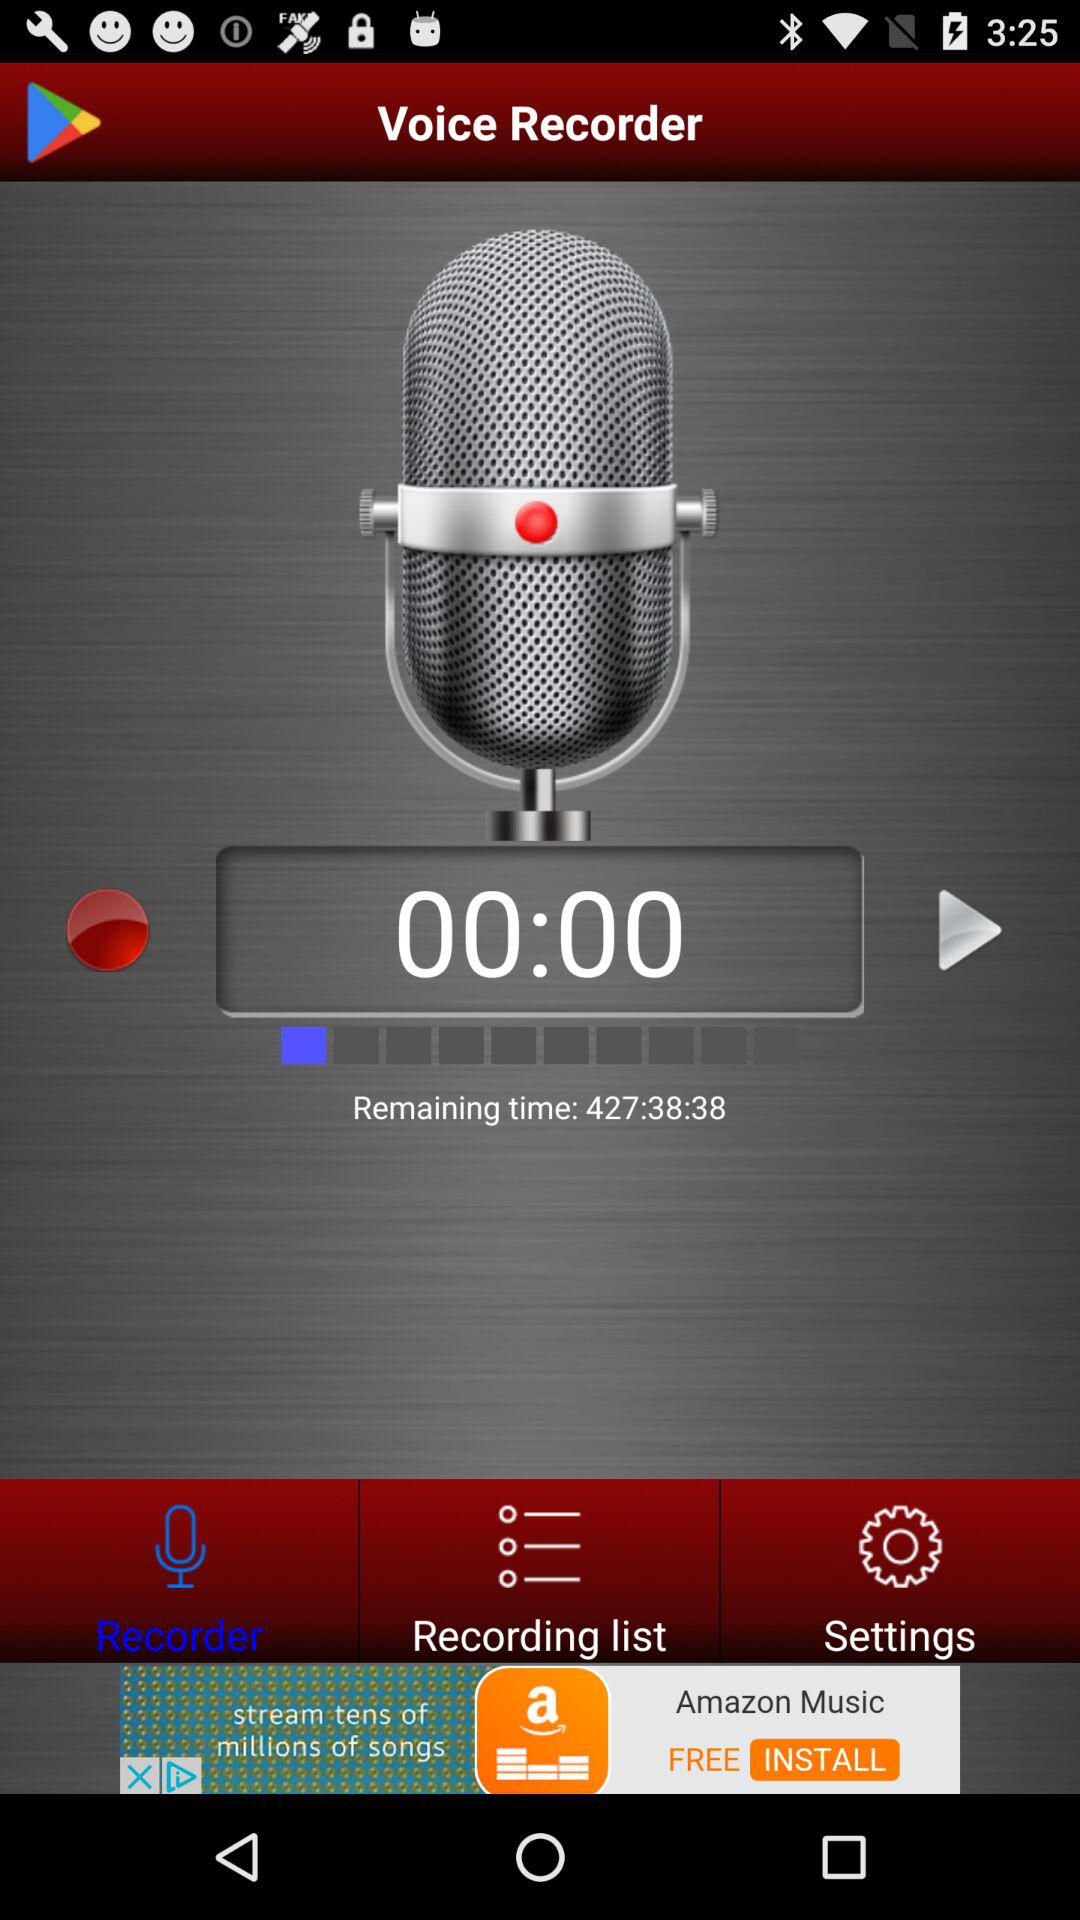What is the selected tab? The selected tab is "Recorder". 